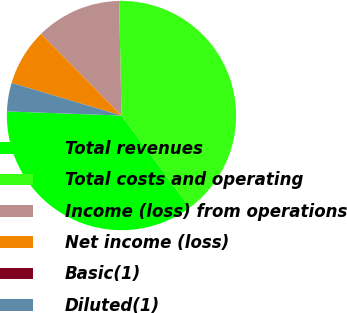<chart> <loc_0><loc_0><loc_500><loc_500><pie_chart><fcel>Total revenues<fcel>Total costs and operating<fcel>Income (loss) from operations<fcel>Net income (loss)<fcel>Basic(1)<fcel>Diluted(1)<nl><fcel>35.73%<fcel>40.17%<fcel>12.05%<fcel>8.03%<fcel>0.0%<fcel>4.02%<nl></chart> 